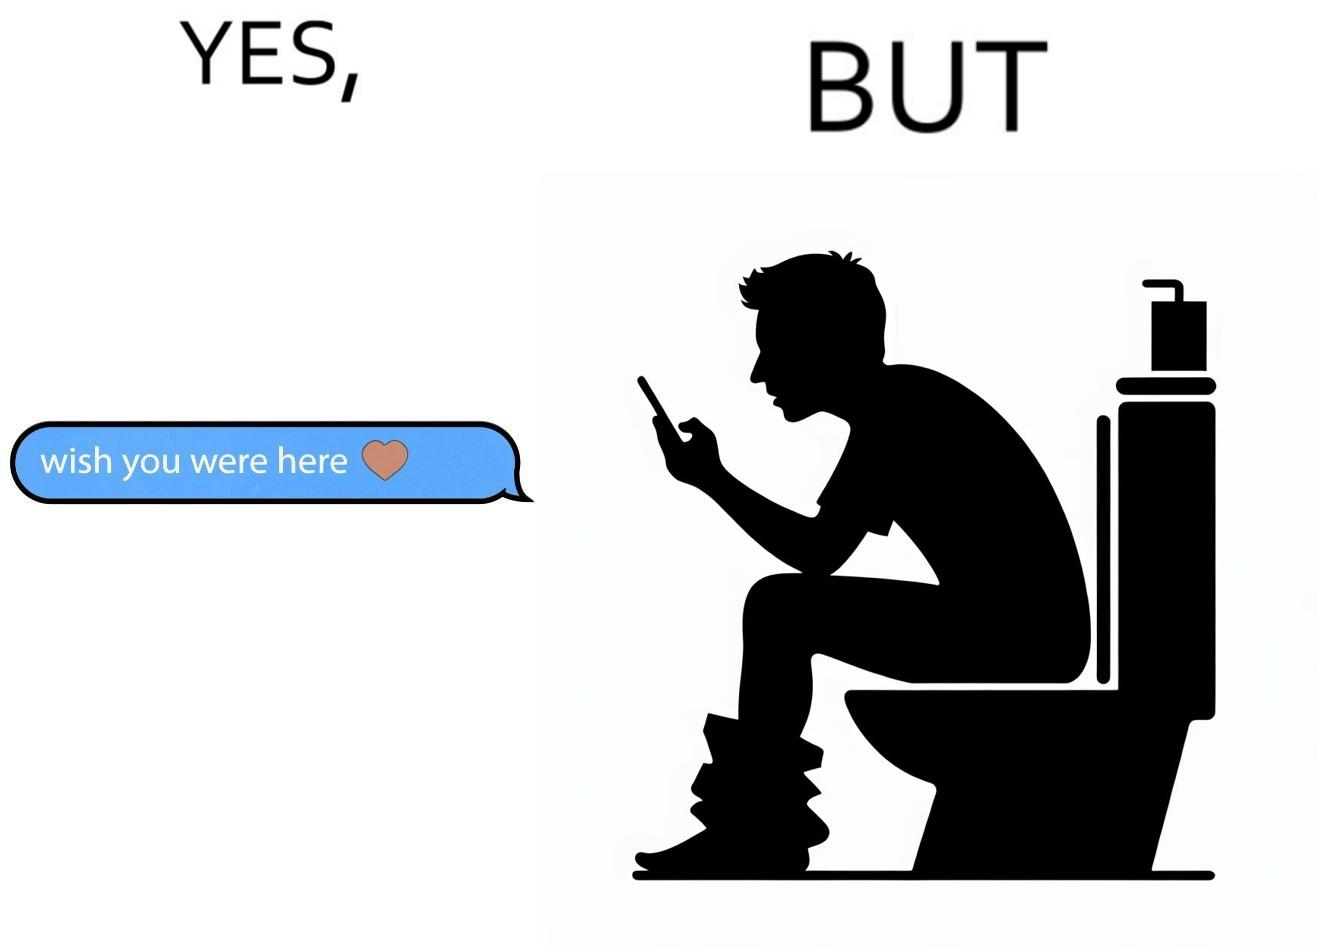What does this image depict? The images are funny since it shows how even though a man writes to his partner that he wishes she was there to show that he misses her, it would be inappropriate and gross if it were to happen literally as he is sitting on his toilet 